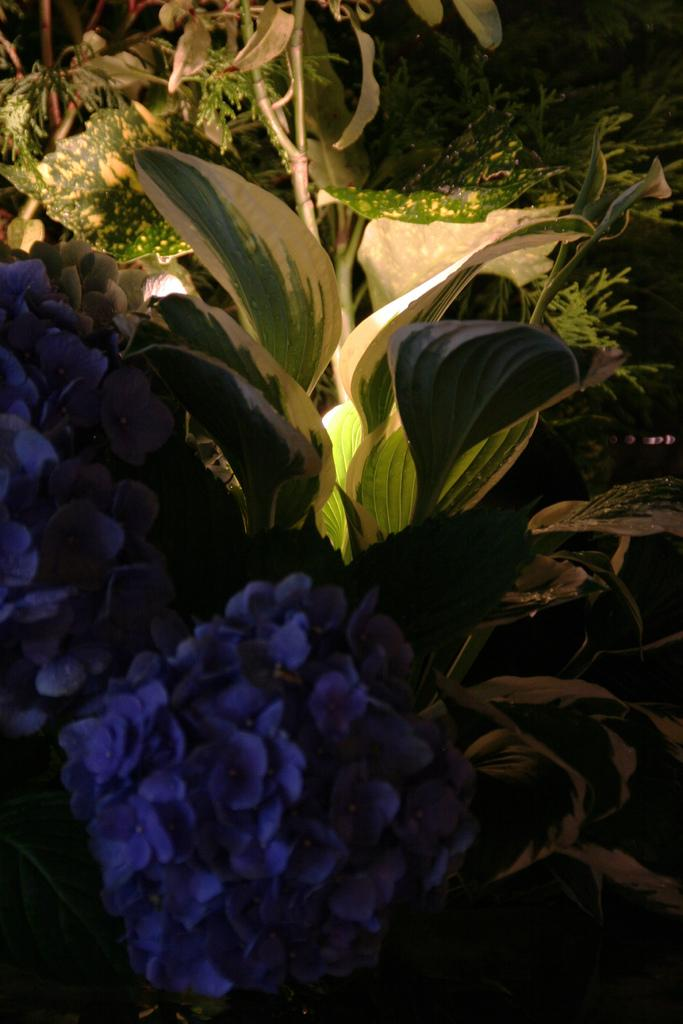What type of living organisms can be seen in the image? There are flowers and plants in the image. Can you describe the plants in the image? The image contains flowers, which are a type of plant. Are there any other types of plants visible in the image? The facts provided do not mention any other types of plants, only flowers. How many beginner attempts were made before successfully growing the flowers in the image? There is no information about attempts or growing processes in the image, so we cannot answer this question. 